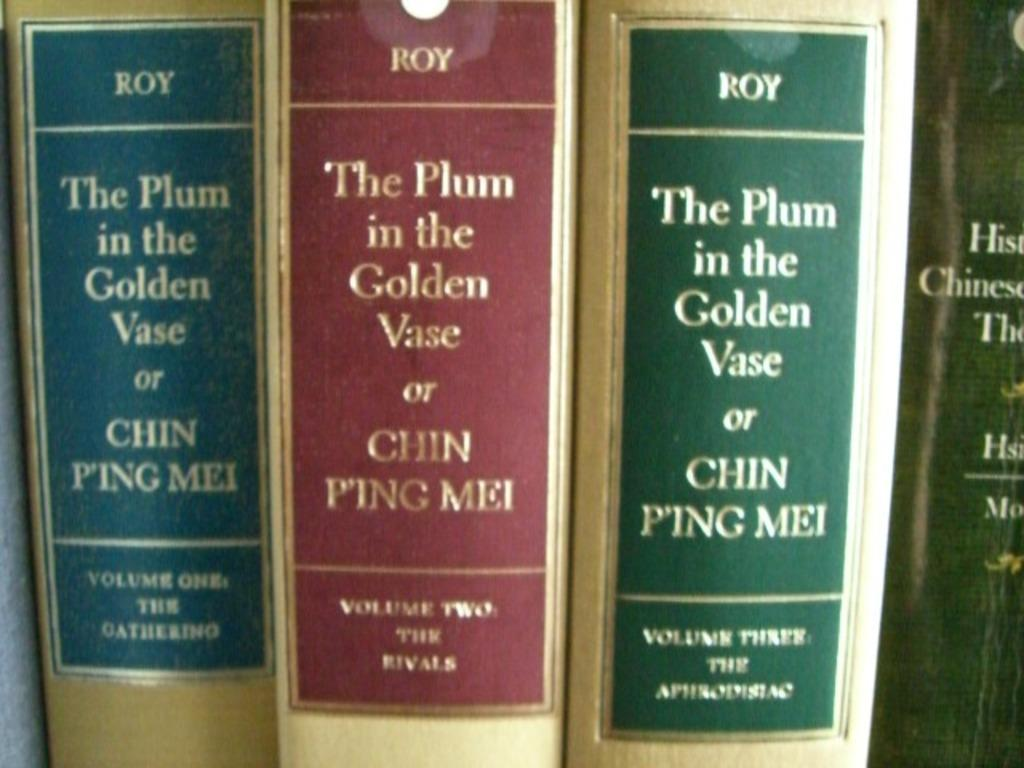Provide a one-sentence caption for the provided image. Three gold books by Roy called The Plum in the Golden Vase or Chin Ping Mei, each with a different color label: blue, red, and green. 